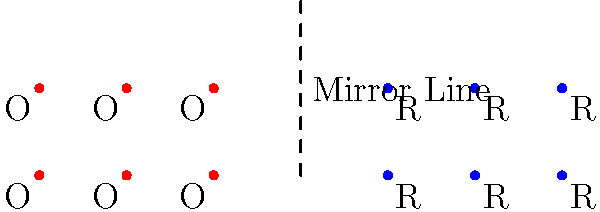In a movie theater, a new seating arrangement is being designed using mirror reflections. The diagram shows the original seats (labeled O) and their reflections (labeled R) across a mirror line. If the original seating arrangement forms a rectangular grid of 2 rows and 3 columns, how many total seats (original and reflected) will be in the new arrangement? Consider how this layout might impact the audience's perception of on-screen violence in crime films. To solve this problem, we need to follow these steps:

1. Count the original seats:
   - There are 2 rows and 3 columns
   - Total original seats = 2 × 3 = 6

2. Understand the reflection:
   - Each original seat is reflected across the mirror line
   - The number of reflected seats is equal to the number of original seats

3. Calculate the total number of seats:
   - Total seats = Original seats + Reflected seats
   - Total seats = 6 + 6 = 12

4. Interpret the result:
   - The new arrangement doubles the seating capacity
   - This layout creates a symmetrical viewing experience

5. Consider the impact on film perception:
   - The mirrored layout might symbolize the duality in crime narratives
   - Increased seating capacity could lead to a more diverse audience, potentially diluting the glorification of violence
   - The symmetrical arrangement might encourage viewers to reflect on the balanced nature of justice in crime fiction
Answer: 12 seats 